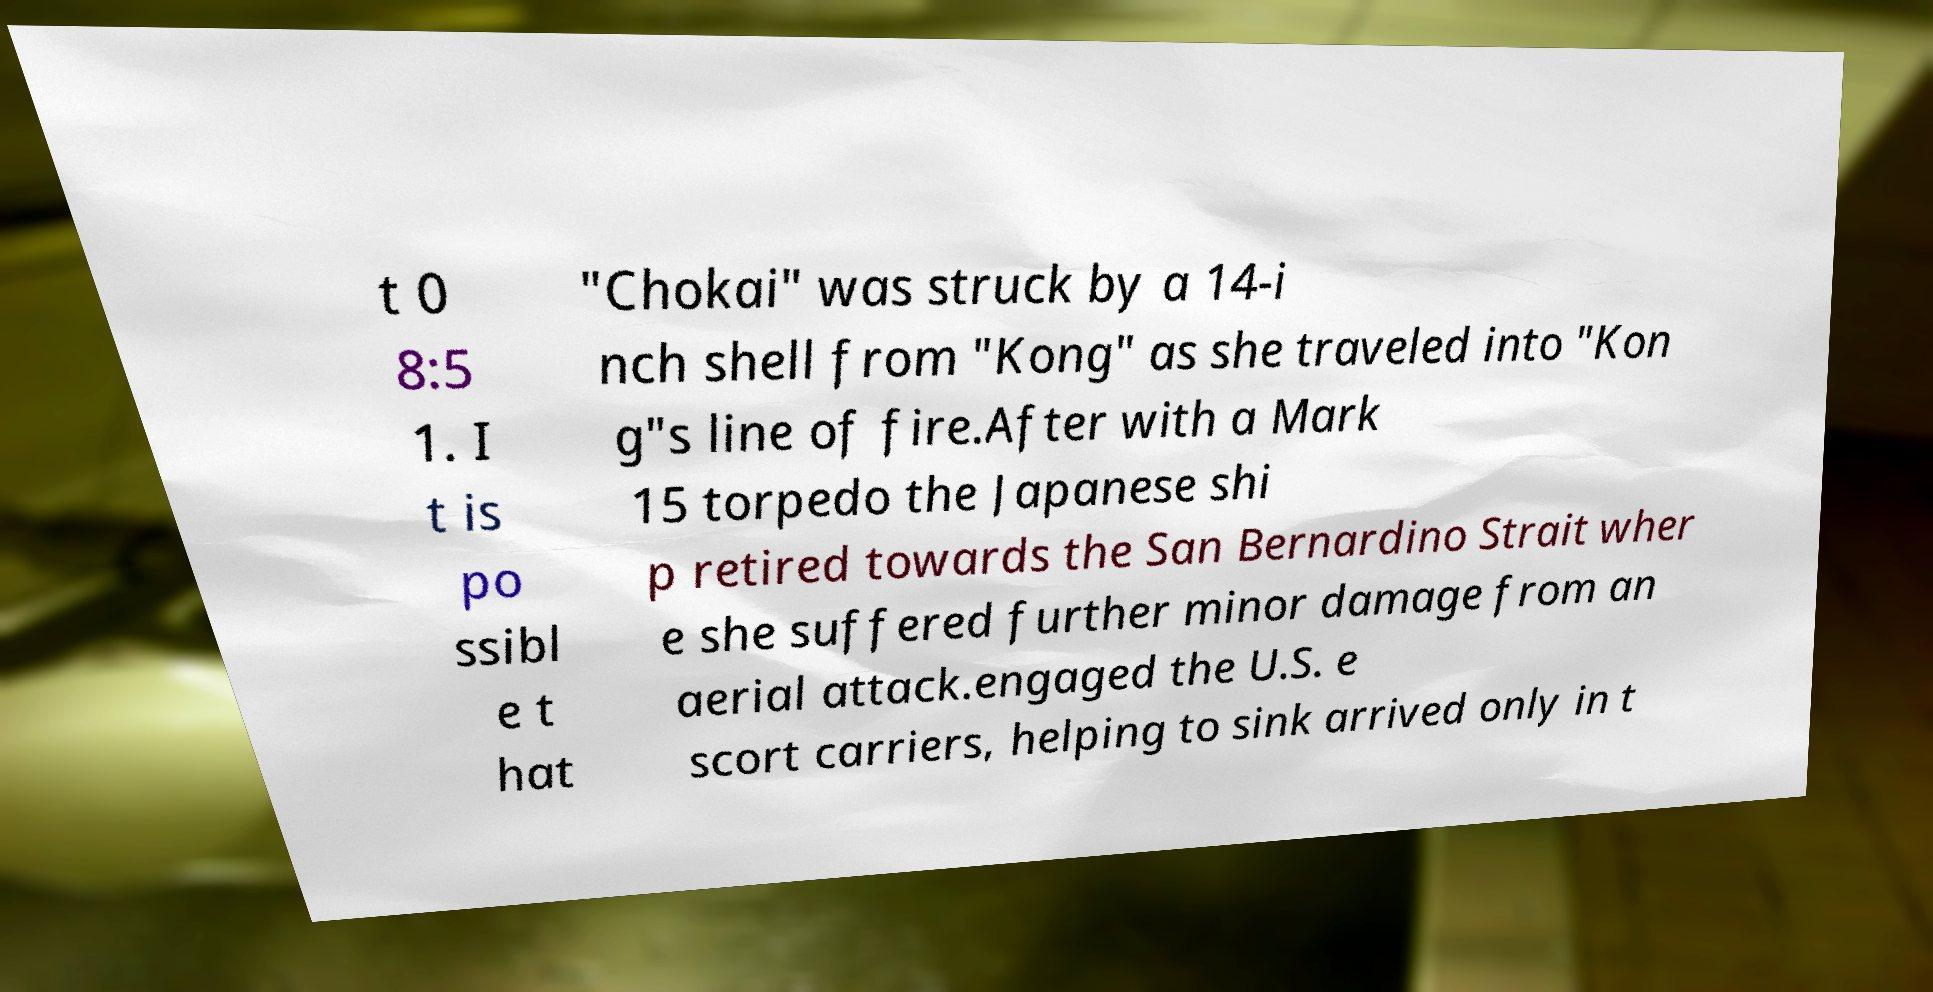Can you accurately transcribe the text from the provided image for me? t 0 8:5 1. I t is po ssibl e t hat "Chokai" was struck by a 14-i nch shell from "Kong" as she traveled into "Kon g"s line of fire.After with a Mark 15 torpedo the Japanese shi p retired towards the San Bernardino Strait wher e she suffered further minor damage from an aerial attack.engaged the U.S. e scort carriers, helping to sink arrived only in t 